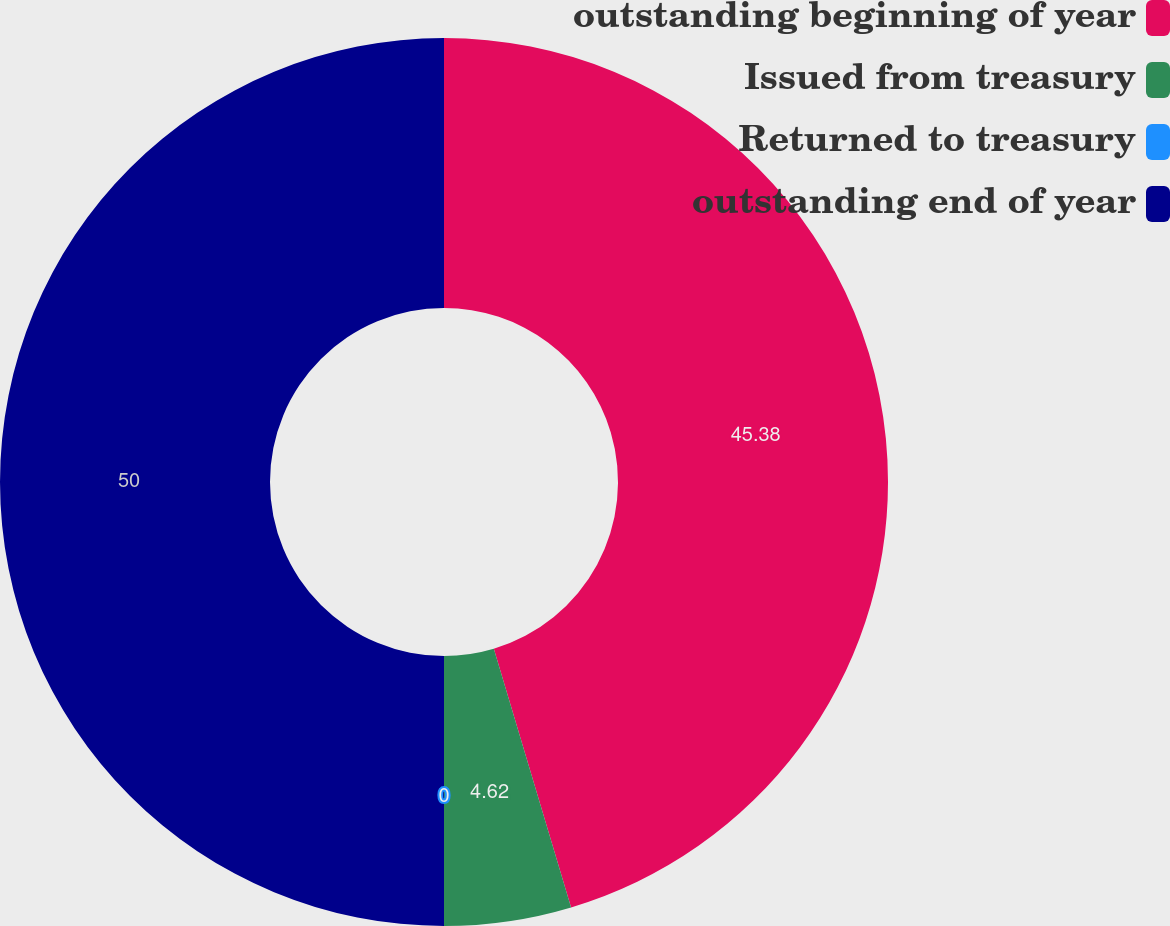Convert chart. <chart><loc_0><loc_0><loc_500><loc_500><pie_chart><fcel>outstanding beginning of year<fcel>Issued from treasury<fcel>Returned to treasury<fcel>outstanding end of year<nl><fcel>45.38%<fcel>4.62%<fcel>0.0%<fcel>50.0%<nl></chart> 